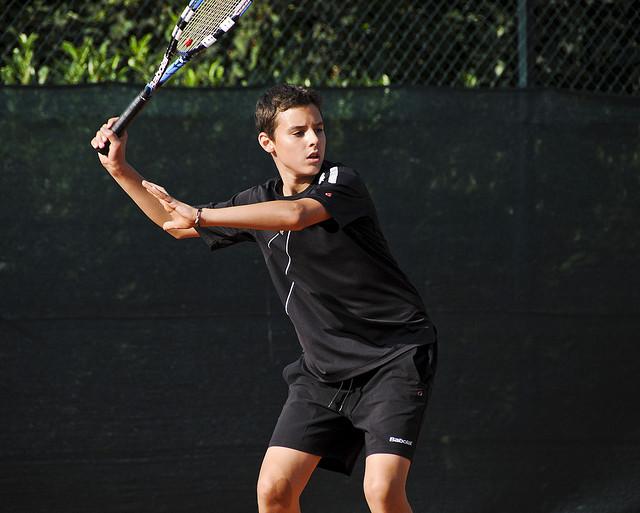What color is the racket?
Quick response, please. Black. What is the blue and black object on this man's right side?
Keep it brief. Racket. What is the man wearing on his wrist?
Quick response, please. Watch. Where is the man's right leg?
Quick response, please. On ground. Why does the boy have a racket?
Short answer required. Playing tennis. How many bracelets is the player wearing?
Write a very short answer. 1. Is the guy wearing shorts or pants?
Write a very short answer. Shorts. Is the man serving the ball?
Write a very short answer. No. 